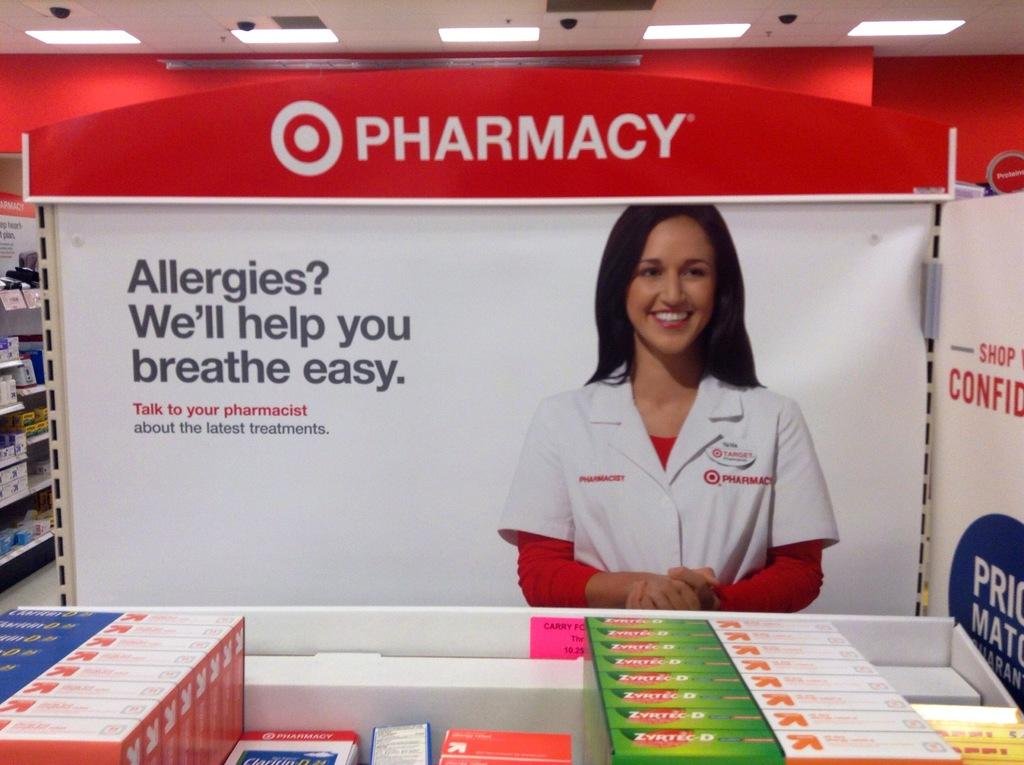<image>
Describe the image concisely. a Pharmacy sign for Allergies with a smiling lady on it 